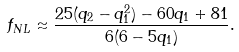<formula> <loc_0><loc_0><loc_500><loc_500>f _ { N L } \approx \frac { 2 5 ( q _ { 2 } - q _ { 1 } ^ { 2 } ) - 6 0 q _ { 1 } + 8 1 } { 6 ( 6 - 5 q _ { 1 } ) } .</formula> 